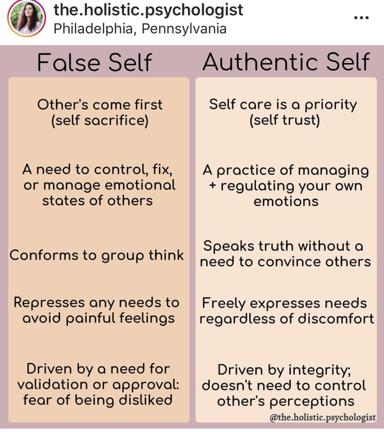What are some differences between the false self and the authentic self according to the image? The image presents a compelling comparison between the false self and the authentic self. For the false self, there's an emphasis on self-sacrifice, emotional control over others, group conformity, repression of personal needs, and a strong dependence on external validation. In contrast, the authentic self is characterized by prioritizing self-care, effectively managing personal emotions, valuing honesty without persuasiveness, expressing needs freely despite potential discomfort, and being driven by personal integrity rather than the approval of others. 